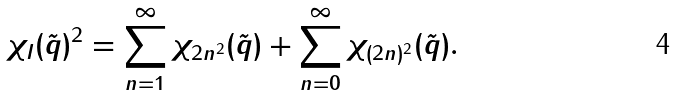<formula> <loc_0><loc_0><loc_500><loc_500>\chi _ { I } ( \tilde { q } ) ^ { 2 } = \sum _ { n = 1 } ^ { \infty } \chi _ { 2 n ^ { 2 } } ( \tilde { q } ) + \sum _ { n = 0 } ^ { \infty } \chi _ { ( 2 n ) ^ { 2 } } ( \tilde { q } ) .</formula> 